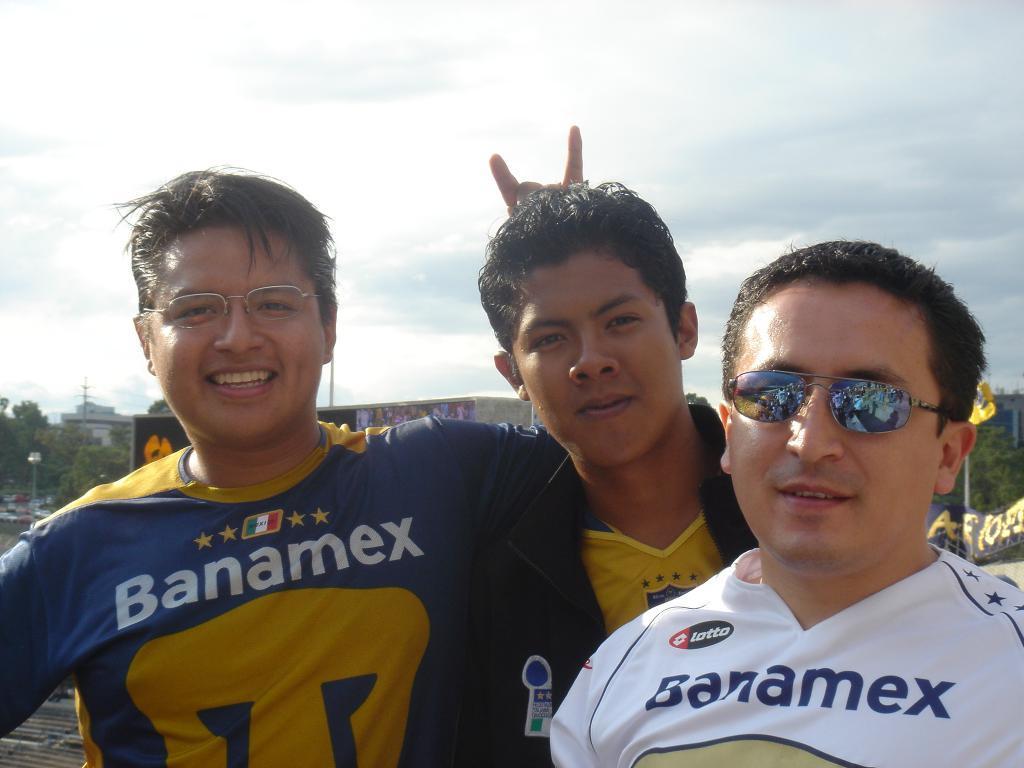Please provide a concise description of this image. In the foreground, I can see three persons. In the background, I can see trees, vehicles on the road, buildings, hoardings, flag poles and the sky. This picture might be taken in a day. 